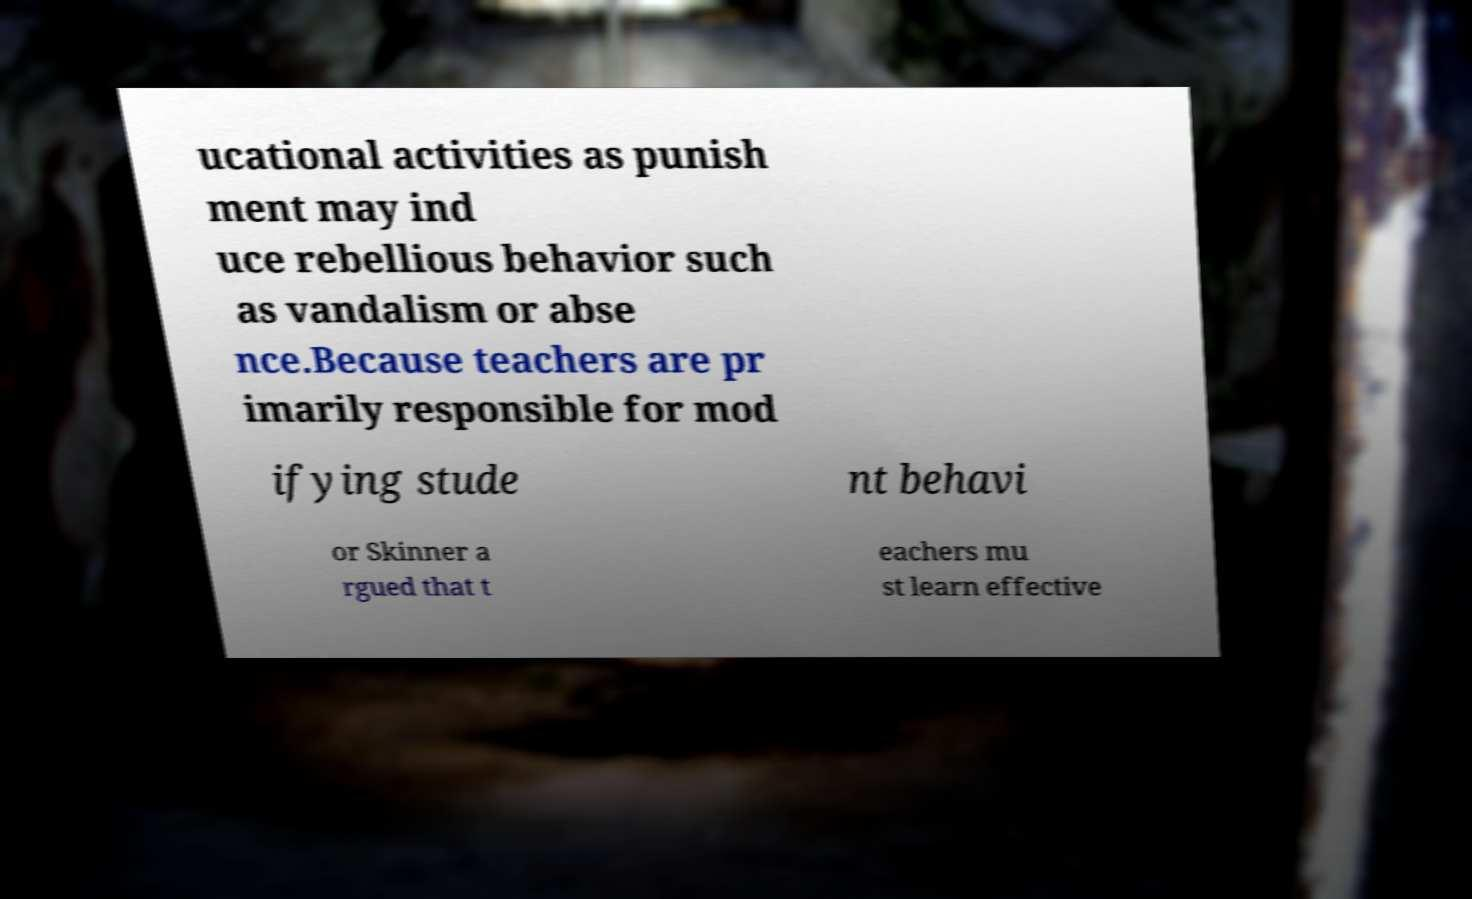Can you read and provide the text displayed in the image?This photo seems to have some interesting text. Can you extract and type it out for me? ucational activities as punish ment may ind uce rebellious behavior such as vandalism or abse nce.Because teachers are pr imarily responsible for mod ifying stude nt behavi or Skinner a rgued that t eachers mu st learn effective 